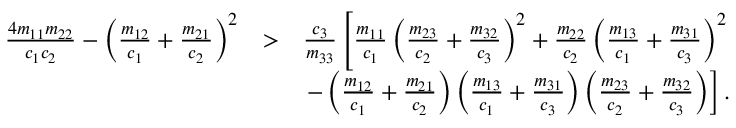<formula> <loc_0><loc_0><loc_500><loc_500>\begin{array} { r l r } { \frac { 4 m _ { 1 1 } m _ { 2 2 } } { c _ { 1 } c _ { 2 } } - \left ( \frac { m _ { 1 2 } } { c _ { 1 } } + \frac { m _ { 2 1 } } { c _ { 2 } } \right ) ^ { 2 } } & { > } & { \frac { c _ { 3 } } { m _ { 3 3 } } \left [ \frac { m _ { 1 1 } } { c _ { 1 } } \left ( \frac { m _ { 2 3 } } { c _ { 2 } } + \frac { m _ { 3 2 } } { c _ { 3 } } \right ) ^ { 2 } + \frac { m _ { 2 2 } } { c _ { 2 } } \left ( \frac { m _ { 1 3 } } { c _ { 1 } } + \frac { m _ { 3 1 } } { c _ { 3 } } \right ) ^ { 2 } } \\ & { - \left ( \frac { m _ { 1 2 } } { c _ { 1 } } + \frac { m _ { 2 1 } } { c _ { 2 } } \right ) \left ( \frac { m _ { 1 3 } } { c _ { 1 } } + \frac { m _ { 3 1 } } { c _ { 3 } } \right ) \left ( \frac { m _ { 2 3 } } { c _ { 2 } } + \frac { m _ { 3 2 } } { c _ { 3 } } \right ) \right ] . } \end{array}</formula> 